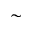Convert formula to latex. <formula><loc_0><loc_0><loc_500><loc_500>\sim</formula> 